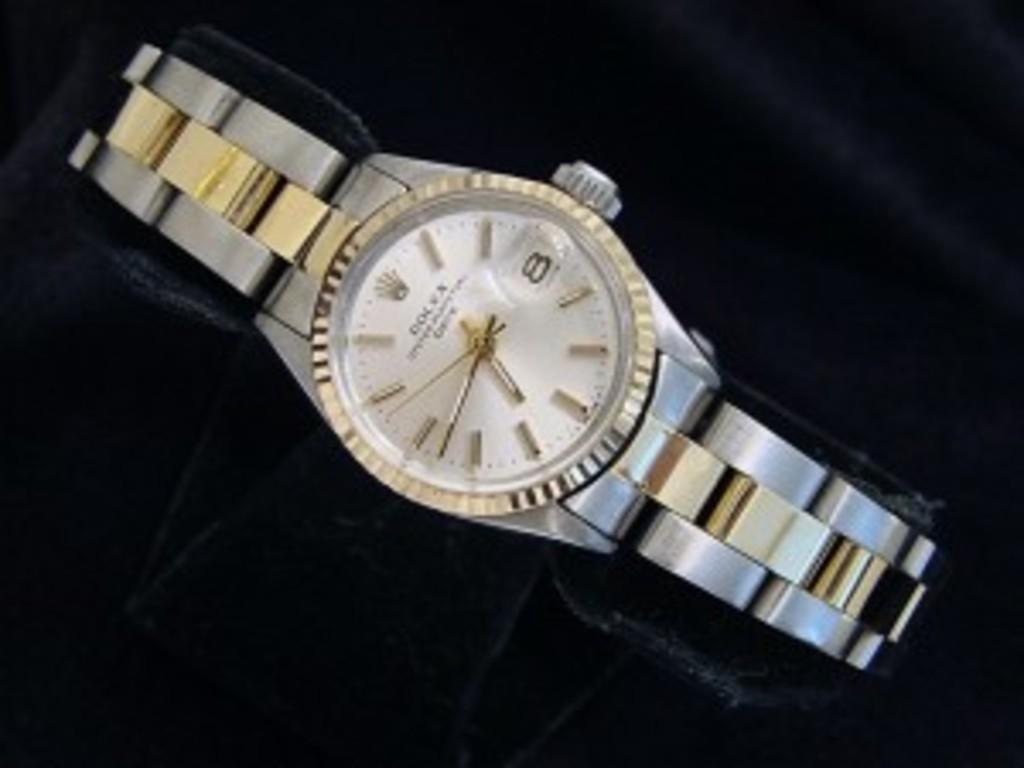<image>
Summarize the visual content of the image. A silver and gold watch says Rolex on the face. 